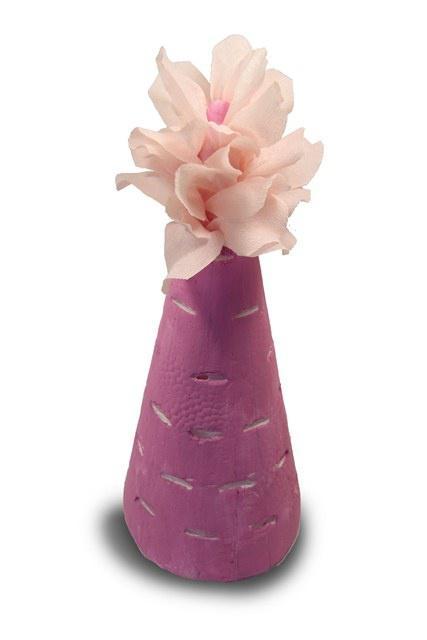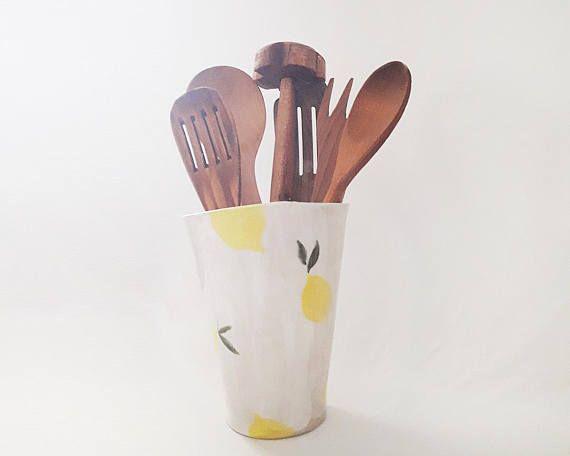The first image is the image on the left, the second image is the image on the right. Considering the images on both sides, is "There is a vase with a wide bottom that tapers to be smaller at the opening holding a single plant in it" valid? Answer yes or no. Yes. 